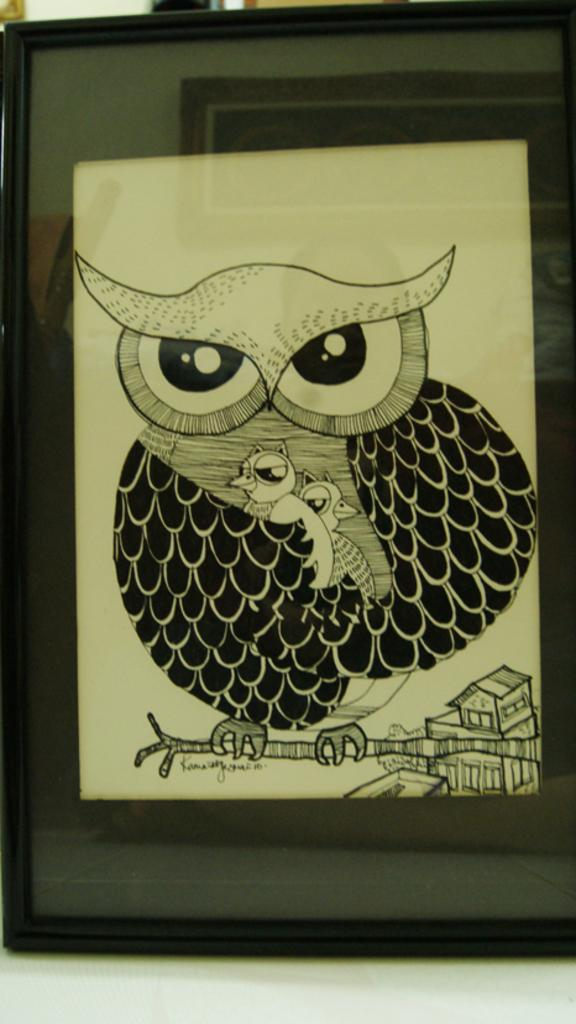What object is present in the image that typically holds a photograph? There is a photo frame in the image. What material covers the front of the photo frame? The photo frame has a glass. What is depicted inside the photo frame? There is a drawing of an owl in the photo frame. What type of sea creature can be seen in the image? There is no sea creature present in the image; it features a photo frame with a drawing of an owl. How does the drawing of the owl express disgust in the image? The drawing of the owl does not express disgust in the image; it is simply a drawing of an owl. 